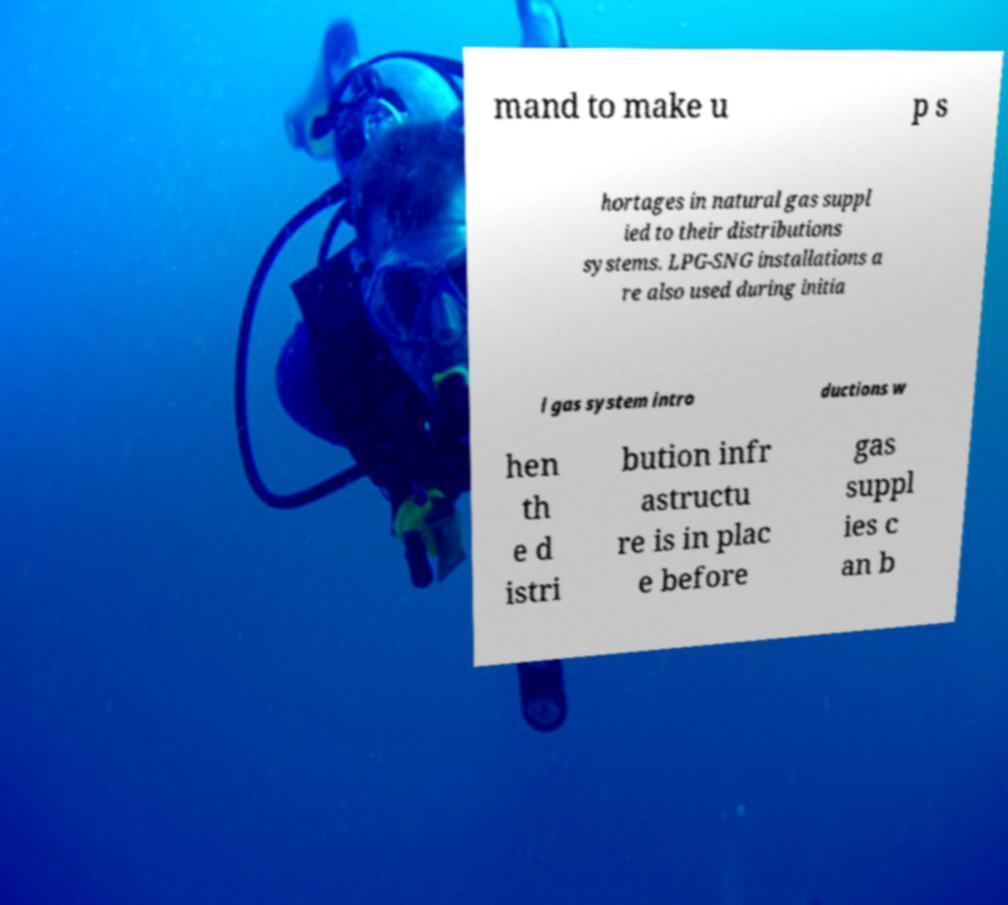Could you assist in decoding the text presented in this image and type it out clearly? mand to make u p s hortages in natural gas suppl ied to their distributions systems. LPG-SNG installations a re also used during initia l gas system intro ductions w hen th e d istri bution infr astructu re is in plac e before gas suppl ies c an b 